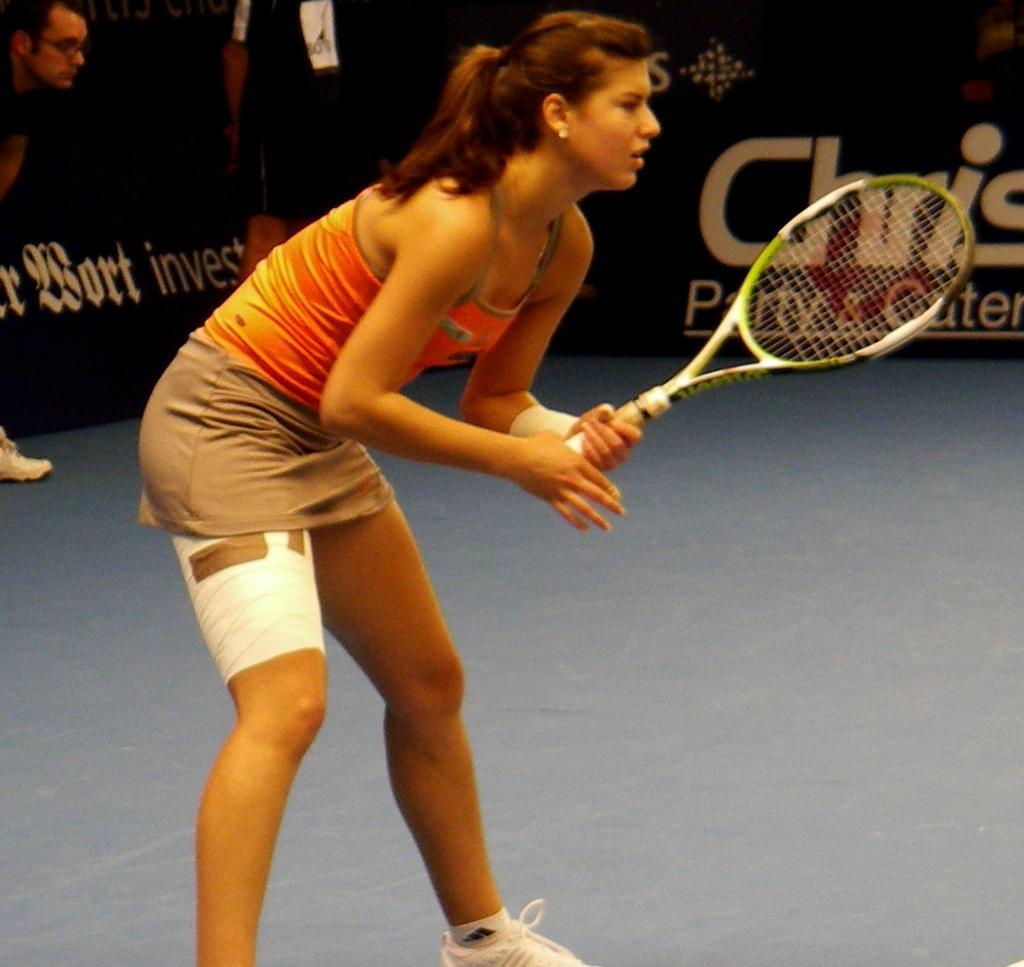In one or two sentences, can you explain what this image depicts? In this image i can see a woman standing and holding the racket. At the back side there is a board and I can see two person standing. The woman is wearing white shoes. 